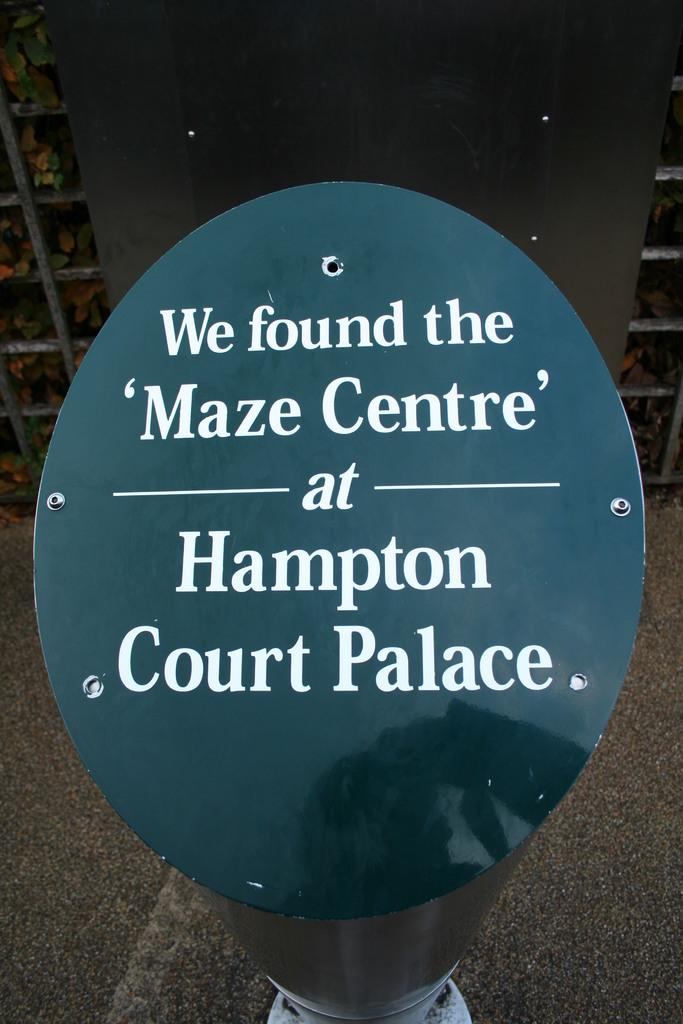What is located in the foreground of the image? There is a pole in the foreground of the image. What is written or displayed on the pole? There is text on the pole. What type of vegetation can be seen in the image? There are plants in shelves at the back of the image. What can be seen at the bottom of the image? There is a road visible at the bottom of the image. How many cats are sitting on the pancake in the image? There are no cats or pancakes present in the image. What type of whip is being used to control the plants in the image? There is no whip present in the image, and the plants are not being controlled by any means shown. 